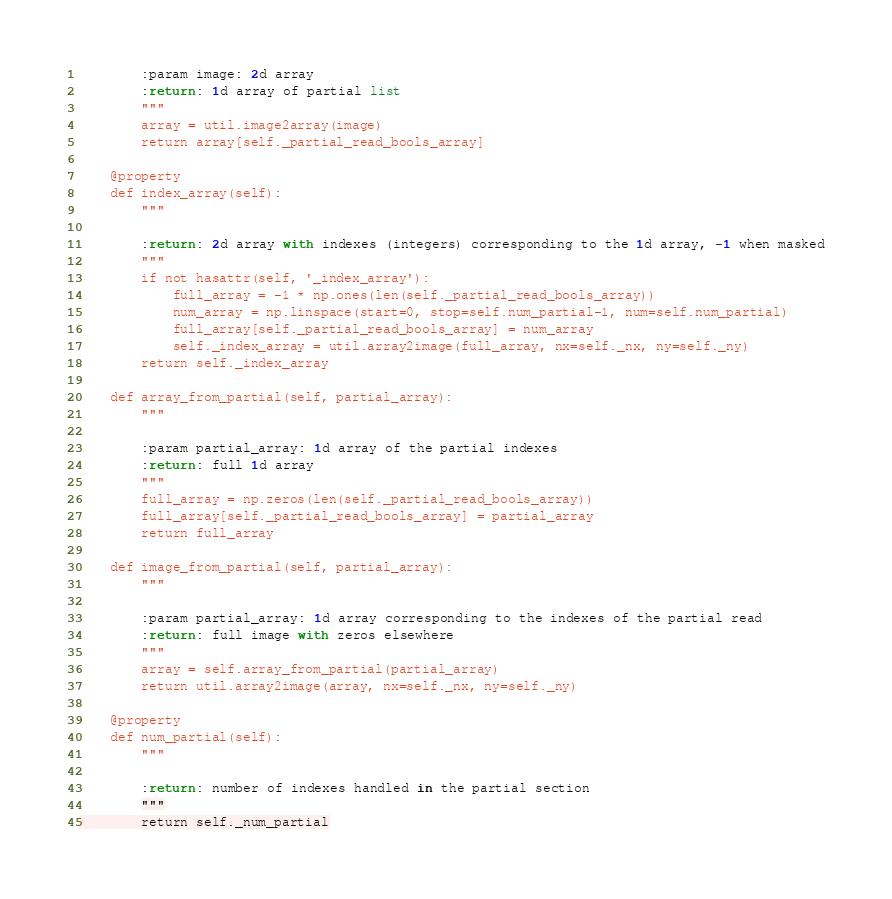<code> <loc_0><loc_0><loc_500><loc_500><_Python_>        :param image: 2d array
        :return: 1d array of partial list
        """
        array = util.image2array(image)
        return array[self._partial_read_bools_array]

    @property
    def index_array(self):
        """

        :return: 2d array with indexes (integers) corresponding to the 1d array, -1 when masked
        """
        if not hasattr(self, '_index_array'):
            full_array = -1 * np.ones(len(self._partial_read_bools_array))
            num_array = np.linspace(start=0, stop=self.num_partial-1, num=self.num_partial)
            full_array[self._partial_read_bools_array] = num_array
            self._index_array = util.array2image(full_array, nx=self._nx, ny=self._ny)
        return self._index_array

    def array_from_partial(self, partial_array):
        """

        :param partial_array: 1d array of the partial indexes
        :return: full 1d array
        """
        full_array = np.zeros(len(self._partial_read_bools_array))
        full_array[self._partial_read_bools_array] = partial_array
        return full_array

    def image_from_partial(self, partial_array):
        """

        :param partial_array: 1d array corresponding to the indexes of the partial read
        :return: full image with zeros elsewhere
        """
        array = self.array_from_partial(partial_array)
        return util.array2image(array, nx=self._nx, ny=self._ny)

    @property
    def num_partial(self):
        """

        :return: number of indexes handled in the partial section
        """
        return self._num_partial
</code> 